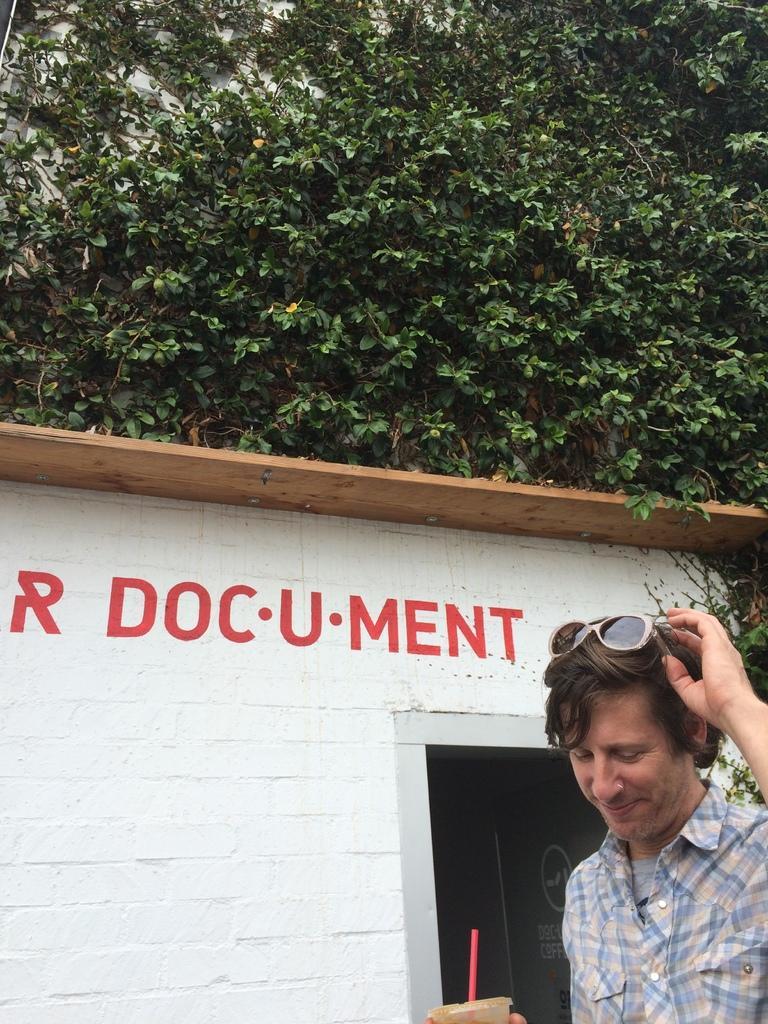Please provide a concise description of this image. In the image we can see a man wearing clothes and the man is smiling. He is holding a glass and straw in the glass. Beside him there is a house and red color text on it. Here we can see a tree. 